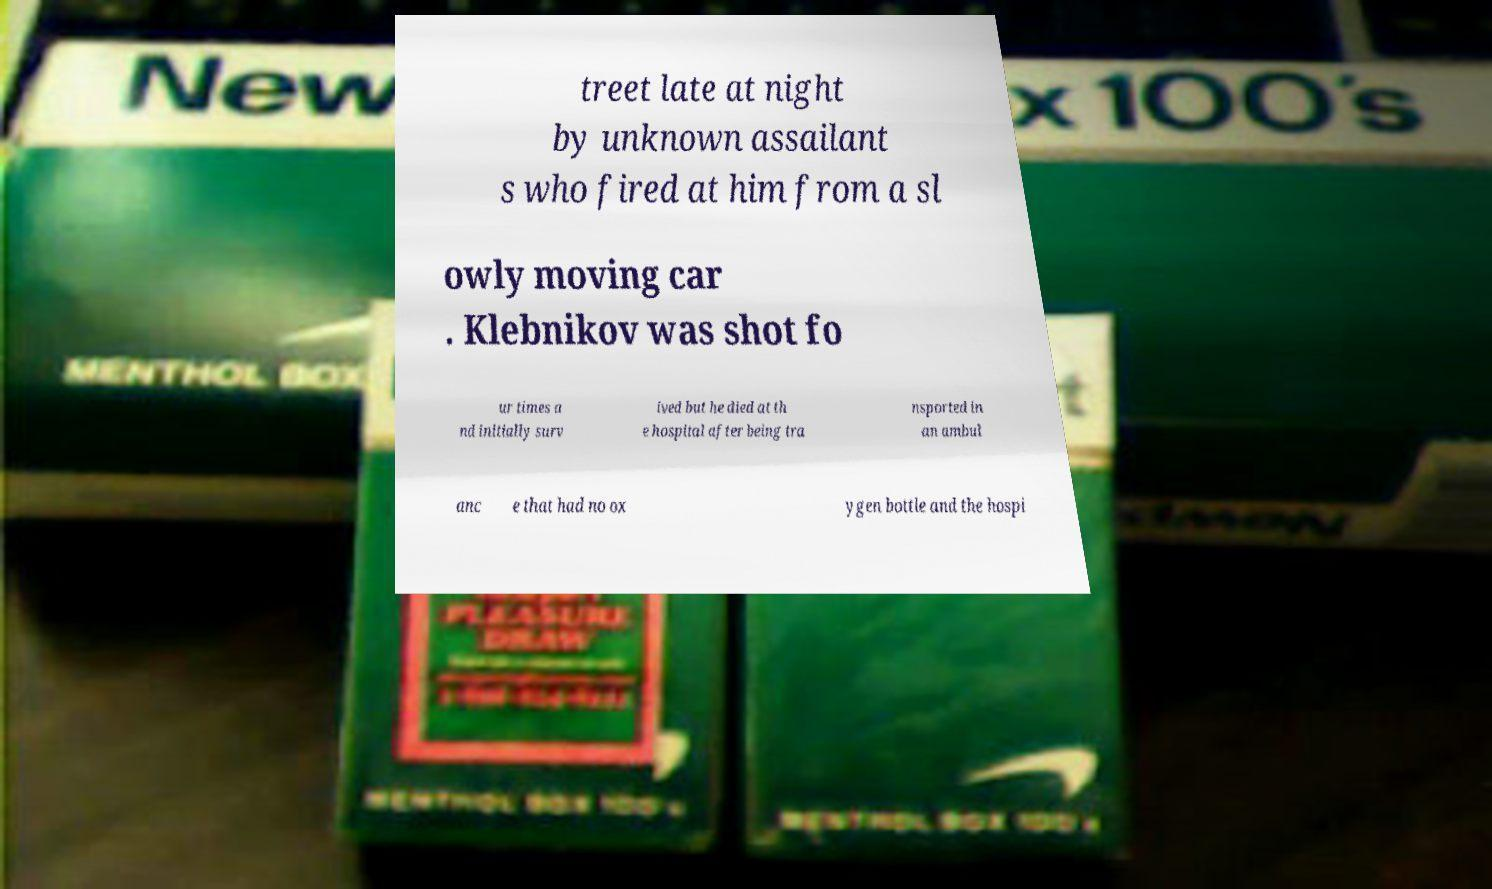For documentation purposes, I need the text within this image transcribed. Could you provide that? treet late at night by unknown assailant s who fired at him from a sl owly moving car . Klebnikov was shot fo ur times a nd initially surv ived but he died at th e hospital after being tra nsported in an ambul anc e that had no ox ygen bottle and the hospi 